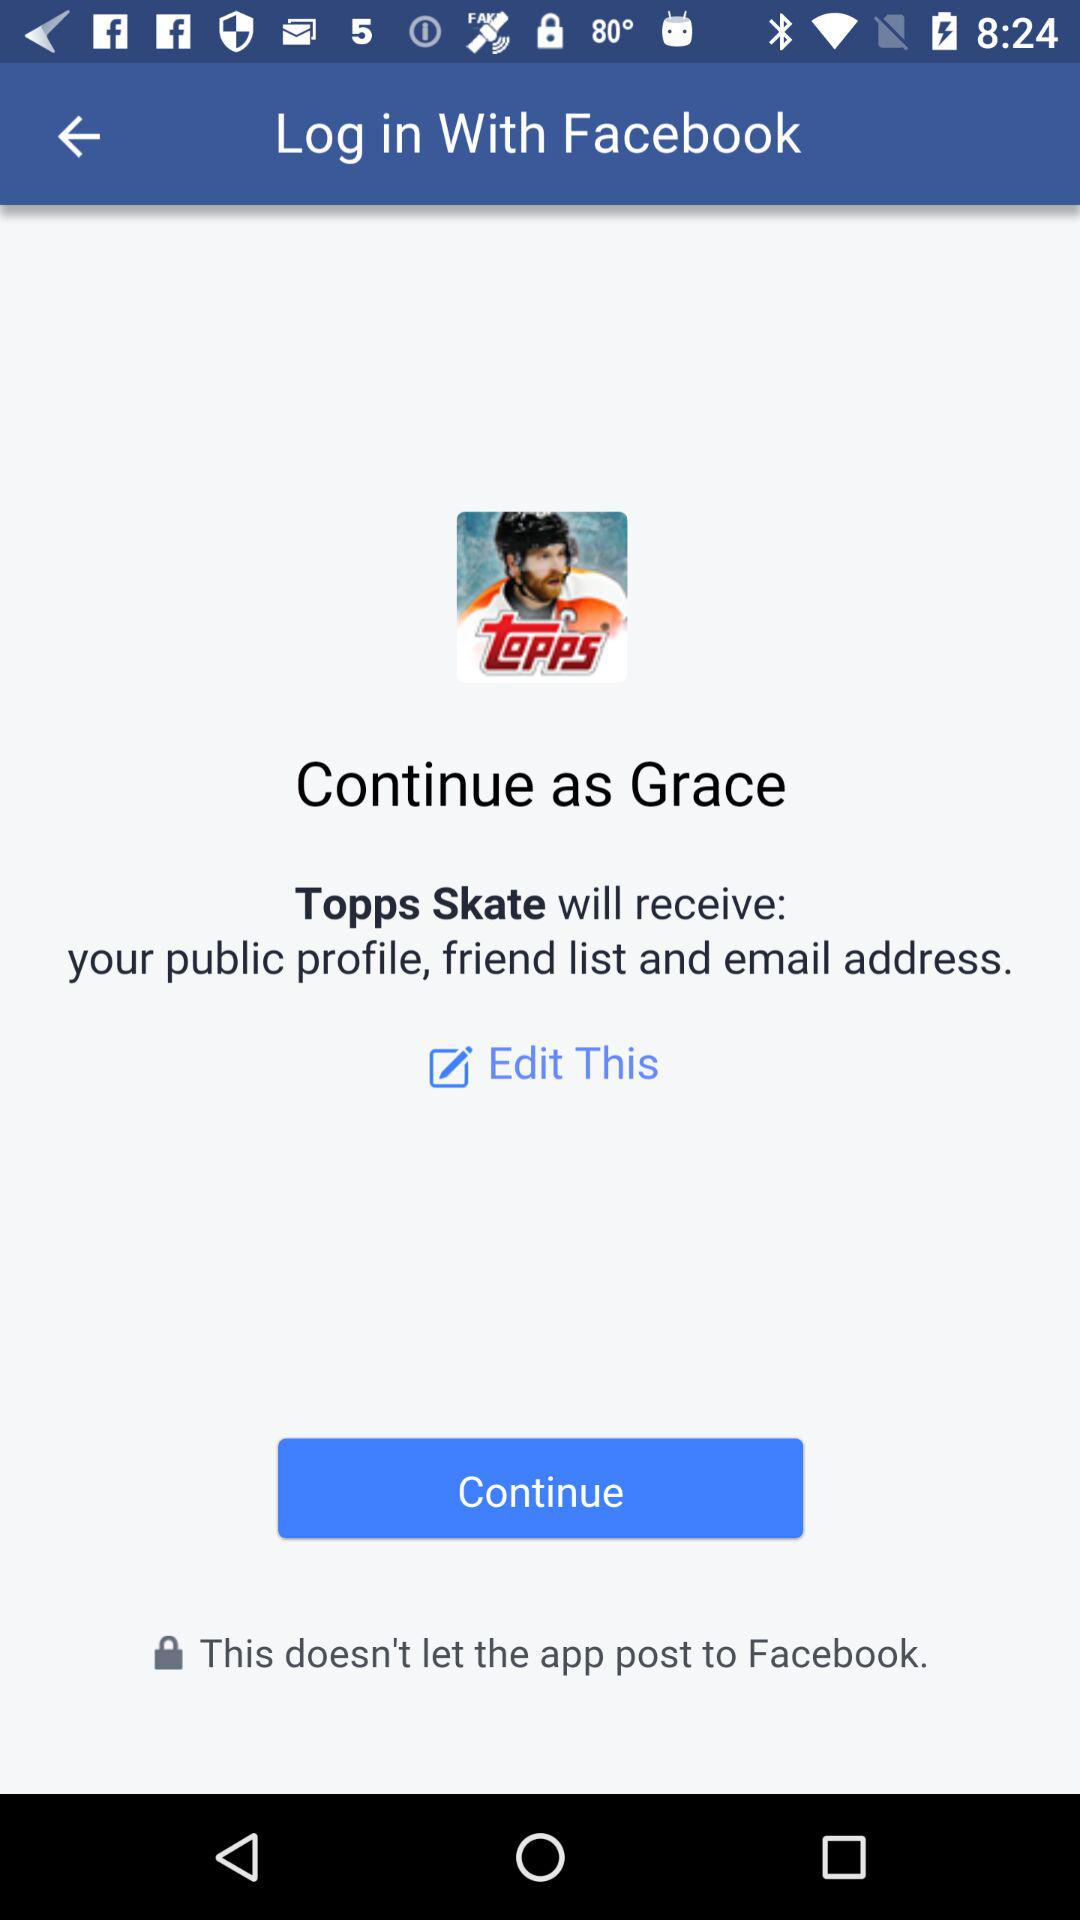Who will receive the public profile, friend list and email address? The application "Topps Skate" will receive the public profile, friend list and email address. 